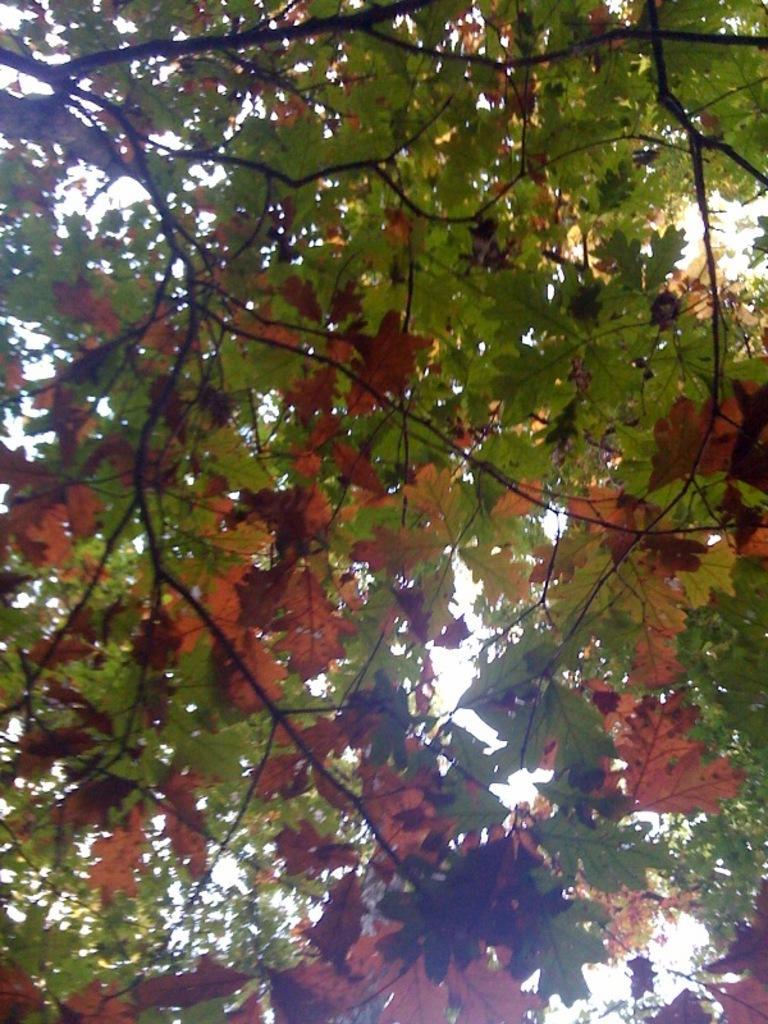How would you summarize this image in a sentence or two? In this image there are trees with red and green color leaves and sky. 